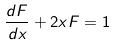Convert formula to latex. <formula><loc_0><loc_0><loc_500><loc_500>\frac { d F } { d x } + 2 x F = 1</formula> 